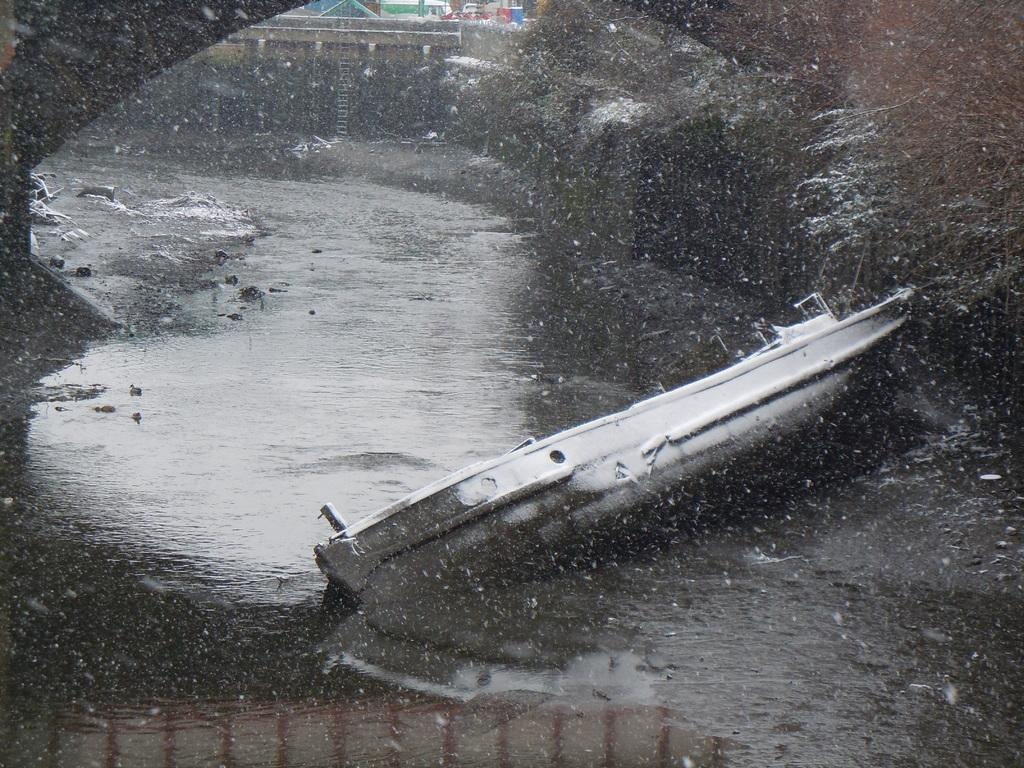What is the main subject of the image? The main subject of the image is a boat. What is the boat doing in the image? The boat is floating on the water in the image. What feature can be seen on the boat? There is a railing visible in the image. What can be seen in the background of the image? There is a lake in the background of the image. What type of story is being told on the stage in the image? There is no stage present in the image; it features a boat floating on water with a railing and a lake in the background. 